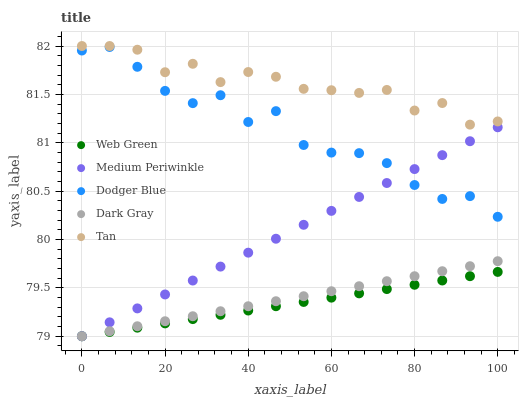Does Web Green have the minimum area under the curve?
Answer yes or no. Yes. Does Tan have the maximum area under the curve?
Answer yes or no. Yes. Does Dodger Blue have the minimum area under the curve?
Answer yes or no. No. Does Dodger Blue have the maximum area under the curve?
Answer yes or no. No. Is Dark Gray the smoothest?
Answer yes or no. Yes. Is Dodger Blue the roughest?
Answer yes or no. Yes. Is Tan the smoothest?
Answer yes or no. No. Is Tan the roughest?
Answer yes or no. No. Does Dark Gray have the lowest value?
Answer yes or no. Yes. Does Dodger Blue have the lowest value?
Answer yes or no. No. Does Tan have the highest value?
Answer yes or no. Yes. Does Dodger Blue have the highest value?
Answer yes or no. No. Is Web Green less than Dodger Blue?
Answer yes or no. Yes. Is Tan greater than Dark Gray?
Answer yes or no. Yes. Does Dark Gray intersect Web Green?
Answer yes or no. Yes. Is Dark Gray less than Web Green?
Answer yes or no. No. Is Dark Gray greater than Web Green?
Answer yes or no. No. Does Web Green intersect Dodger Blue?
Answer yes or no. No. 